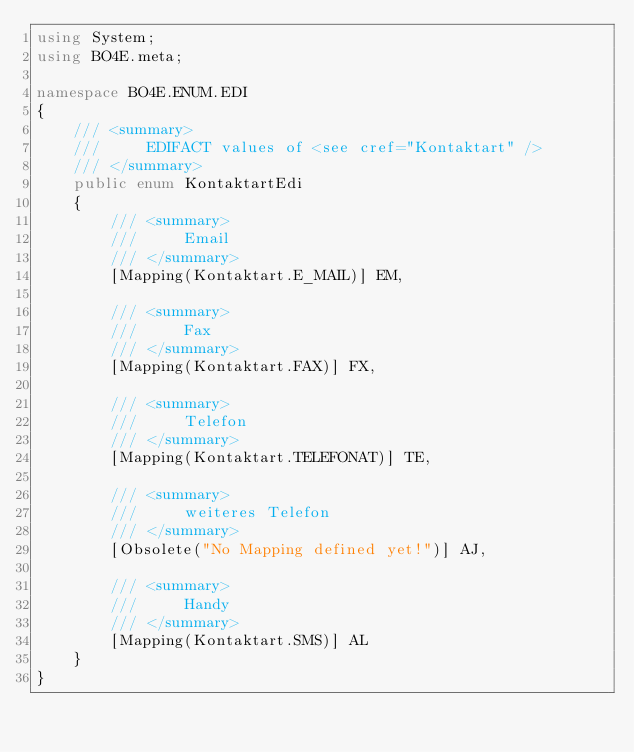Convert code to text. <code><loc_0><loc_0><loc_500><loc_500><_C#_>using System;
using BO4E.meta;

namespace BO4E.ENUM.EDI
{
    /// <summary>
    ///     EDIFACT values of <see cref="Kontaktart" />
    /// </summary>
    public enum KontaktartEdi
    {
        /// <summary>
        ///     Email
        /// </summary>
        [Mapping(Kontaktart.E_MAIL)] EM,

        /// <summary>
        ///     Fax
        /// </summary>
        [Mapping(Kontaktart.FAX)] FX,

        /// <summary>
        ///     Telefon
        /// </summary>
        [Mapping(Kontaktart.TELEFONAT)] TE,

        /// <summary>
        ///     weiteres Telefon
        /// </summary>
        [Obsolete("No Mapping defined yet!")] AJ,

        /// <summary>
        ///     Handy
        /// </summary>
        [Mapping(Kontaktart.SMS)] AL
    }
}</code> 